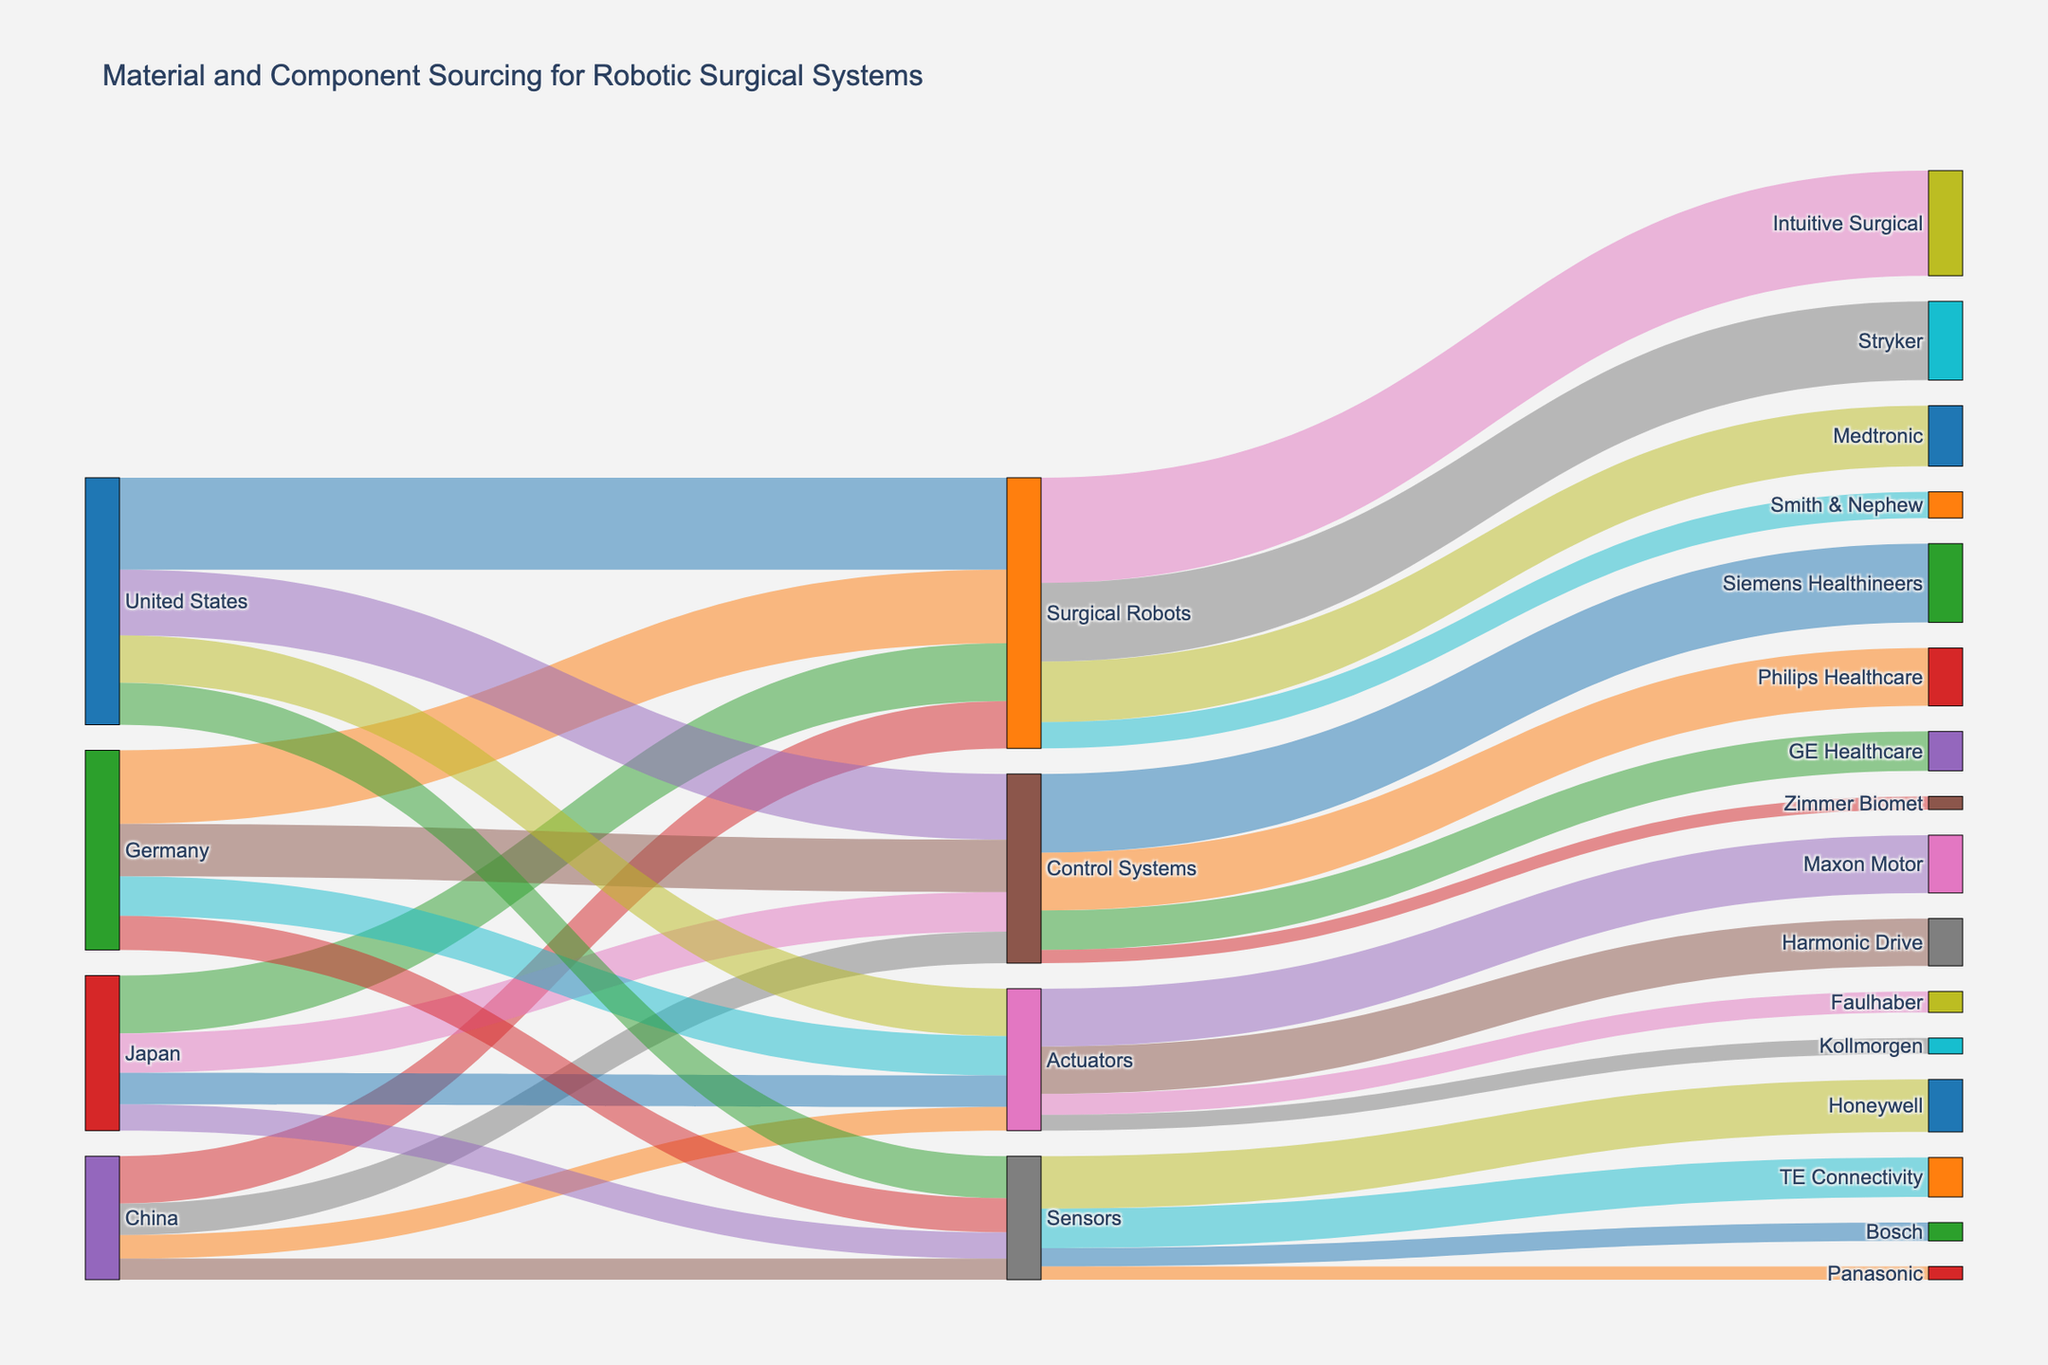What is the title of the Sankey diagram? The title of the Sankey diagram is displayed prominently at the top of the figure.
Answer: "Material and Component Sourcing for Robotic Surgical Systems" Which country contributes the most to Surgical Robots? Look for the largest link flowing into "Surgical Robots" from different countries. The United States has the largest contribution with a value of 3500.
Answer: The United States What is the total contribution of Japan for all components? Sum the contributions from Japan to all destinations: 2200 (Surgical Robots) + 1500 (Control Systems) + 1200 (Actuators) + 1000 (Sensors) = 5900.
Answer: 5900 Which company receives the highest value of Surgical Robots? Look at the links flowing out of "Surgical Robots" and identify the link with the highest value. Intuitive Surgical receives the largest amount with a value of 4000.
Answer: Intuitive Surgical Compare the contribution of Germany and China to Sensors; which one is higher? Check the values of links from Germany to "Sensors" and China to "Sensors": Germany contributes 1300, and China contributes 800. Germany's contribution is higher.
Answer: Germany How many companies source Actuators? Count the unique destinations that receive "Actuators": Maxon Motor, Harmonic Drive, Faulhaber, and Kollmorgen. There are four companies.
Answer: 4 What is the average value of contributions to Control Systems? Sum the contributions to "Control Systems" from all countries and then divide by the number of countries: (2500 + 2000 + 1500 + 1200) / 4 = 7200 / 4 = 1800.
Answer: 1800 What is the total value sourced to Siemens Healthineers and Philips Healthcare combined? Add the contributions to Siemens Healthineers and Philips Healthcare from "Control Systems": 3000 (Siemens Healthineers) + 2200 (Philips Healthcare) = 5200.
Answer: 5200 Which component has the smallest total contribution from all countries? Sum the contributions from all countries to each component and compare to find the smallest. Sensors: 1600 + 1300 + 1000 + 800 = 4700; Actuators: 1800 + 1500 + 1200 + 900 = 5400; Control Systems: 2500 + 2000 + 1500 + 1200 = 7200; Surgical Robots: 3500 + 2800 + 2200 + 1800 = 10300. Sensors have the smallest total contribution.
Answer: Sensors What is the total value of sensors received by all companies? Sum the contributions flowing from "Sensors" to all companies: 2000 (Honeywell) + 1500 (TE Connectivity) + 700 (Bosch) + 500 (Panasonic) = 4700.
Answer: 4700 